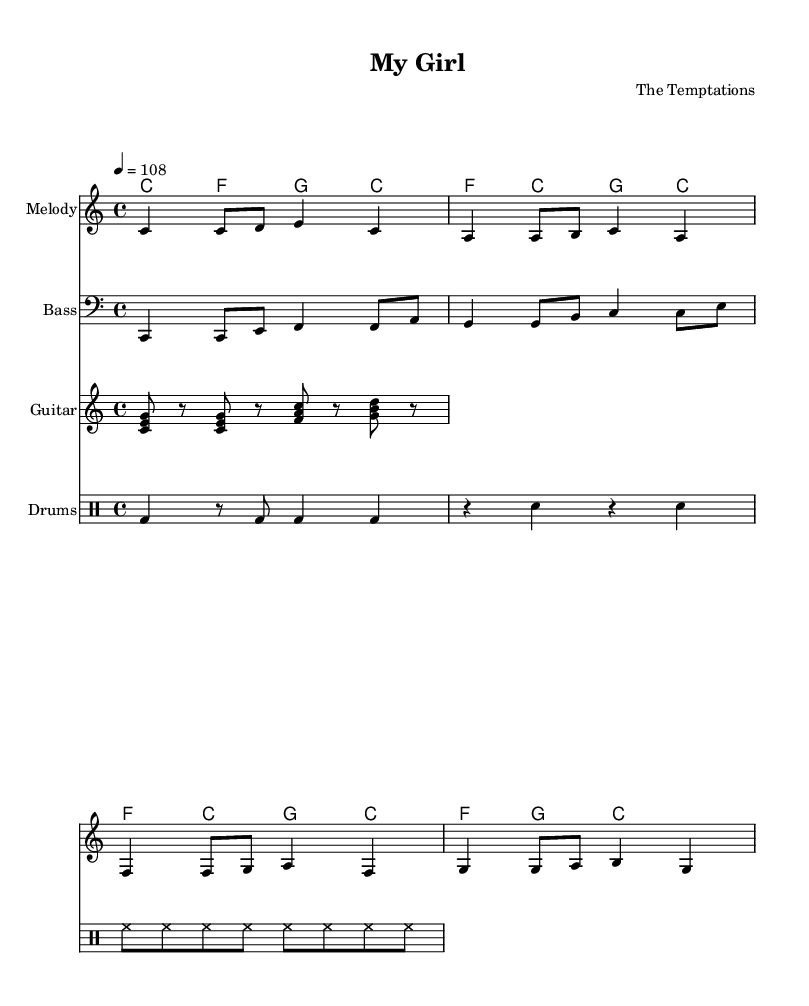What is the key signature of this music? The key signature is C major, which has no sharps or flats indicated in the music.
Answer: C major What is the time signature of this music? The time signature, visible at the beginning of the piece, is 4/4, which indicates four beats per measure.
Answer: 4/4 What is the tempo marking of this music? The tempo marking shows 4 = 108, indicating the quarter note should be played at 108 beats per minute.
Answer: 108 How many measures are in the melody section? By counting the measures from the melody part, there are four distinct measures in total.
Answer: 4 Which instruments are included in this score? The score includes a melody, bass, guitar, and drums, each represented by a separate staff for clarity.
Answer: Melody, Bass, Guitar, Drums How many different chords are used in the harmonies section? The harmonies section contains four distinct chord changes, each represented clearly in the chord mode notation.
Answer: 4 What characteristic rhythm is present in the drum part? The drum part includes a consistent steady rhythm, with the bass drum highlighted at the beginning of the loop, typical in Rhythm and Blues styles.
Answer: Steady rhythm 